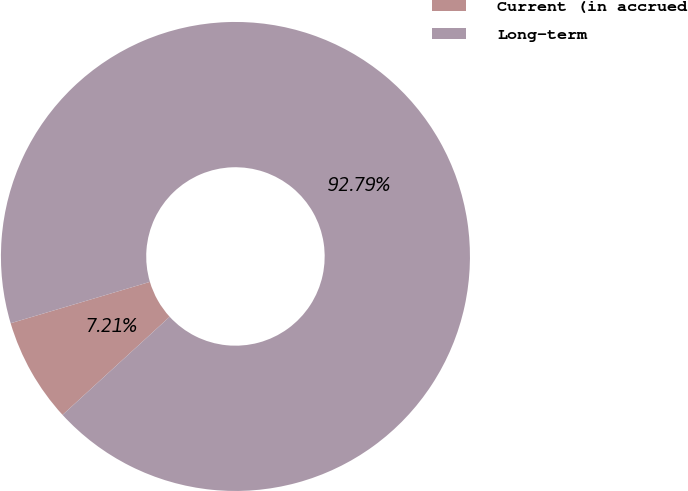Convert chart. <chart><loc_0><loc_0><loc_500><loc_500><pie_chart><fcel>Current (in accrued<fcel>Long-term<nl><fcel>7.21%<fcel>92.79%<nl></chart> 